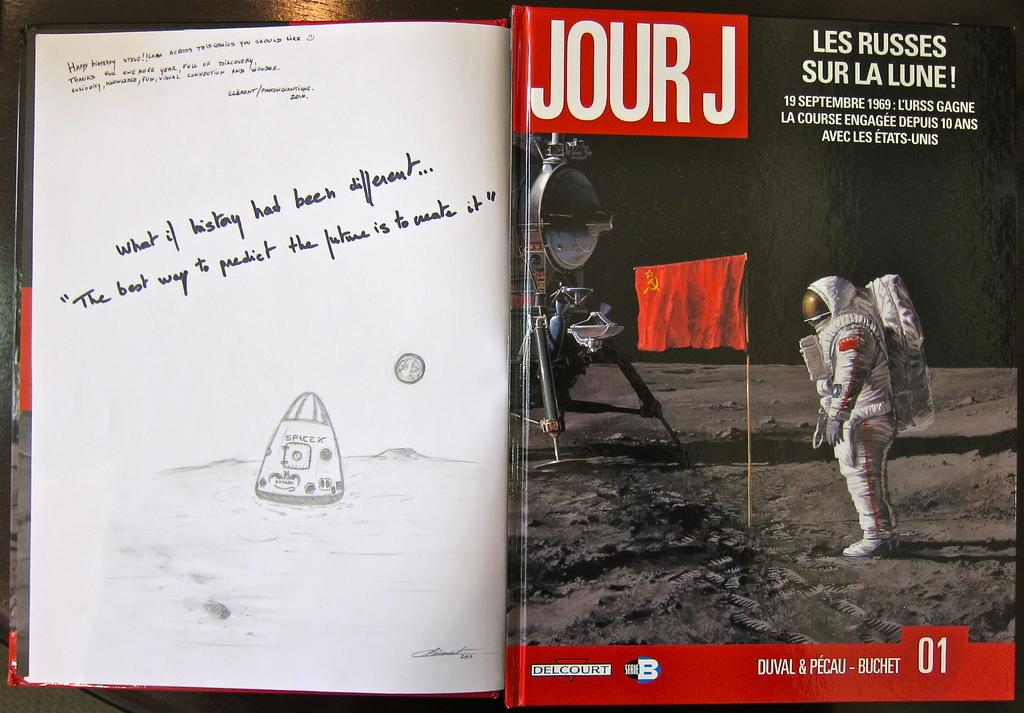What is the french name for the moon?
Your response must be concise. Lune. What is the name of the book?
Keep it short and to the point. Jour j. 